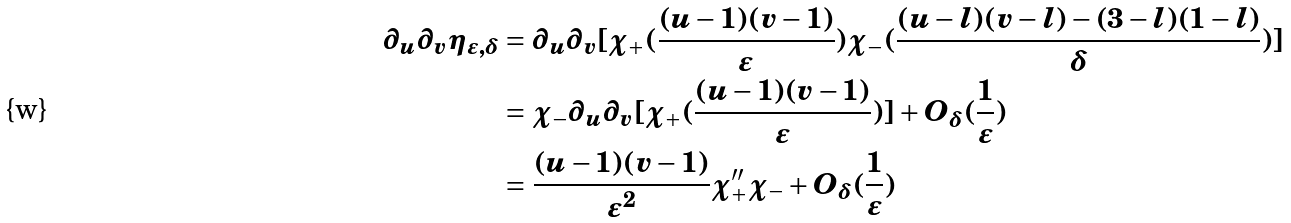<formula> <loc_0><loc_0><loc_500><loc_500>\partial _ { u } \partial _ { v } \eta _ { \varepsilon , \delta } & = \partial _ { u } \partial _ { v } [ \chi _ { + } ( \frac { ( u - 1 ) ( v - 1 ) } { \varepsilon } ) \chi _ { - } ( \frac { ( u - l ) ( v - l ) - ( 3 - l ) ( 1 - l ) } { \delta } ) ] \\ & = \chi _ { - } \partial _ { u } \partial _ { v } [ \chi _ { + } ( \frac { ( u - 1 ) ( v - 1 ) } { \varepsilon } ) ] + O _ { \delta } ( \frac { 1 } { \varepsilon } ) \\ & = \frac { ( u - 1 ) ( v - 1 ) } { \varepsilon ^ { 2 } } \chi _ { + } ^ { \prime \prime } \chi _ { - } + O _ { \delta } ( \frac { 1 } { \varepsilon } )</formula> 